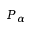Convert formula to latex. <formula><loc_0><loc_0><loc_500><loc_500>P _ { \alpha }</formula> 